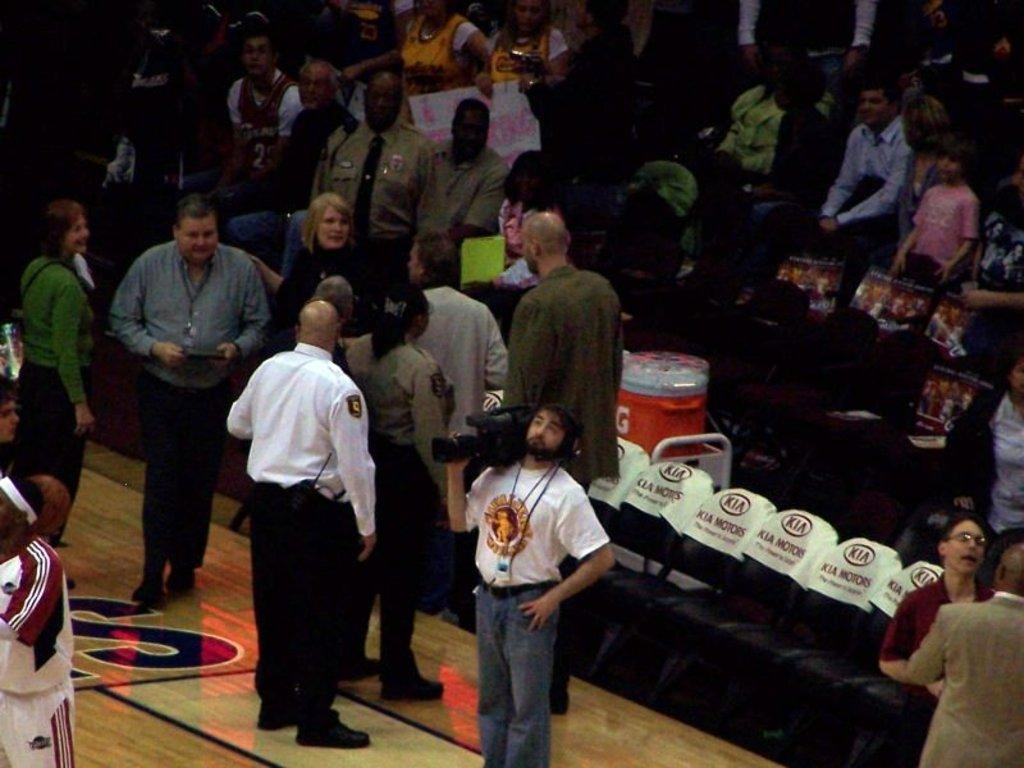What are the people in the image doing? There are people standing and sitting on chairs in the image. What can be seen beneath the people in the image? The floor is visible in the image. What type of ink is being used by the people in the image? There is no ink present in the image, as it does not depict any writing or drawing activity. 